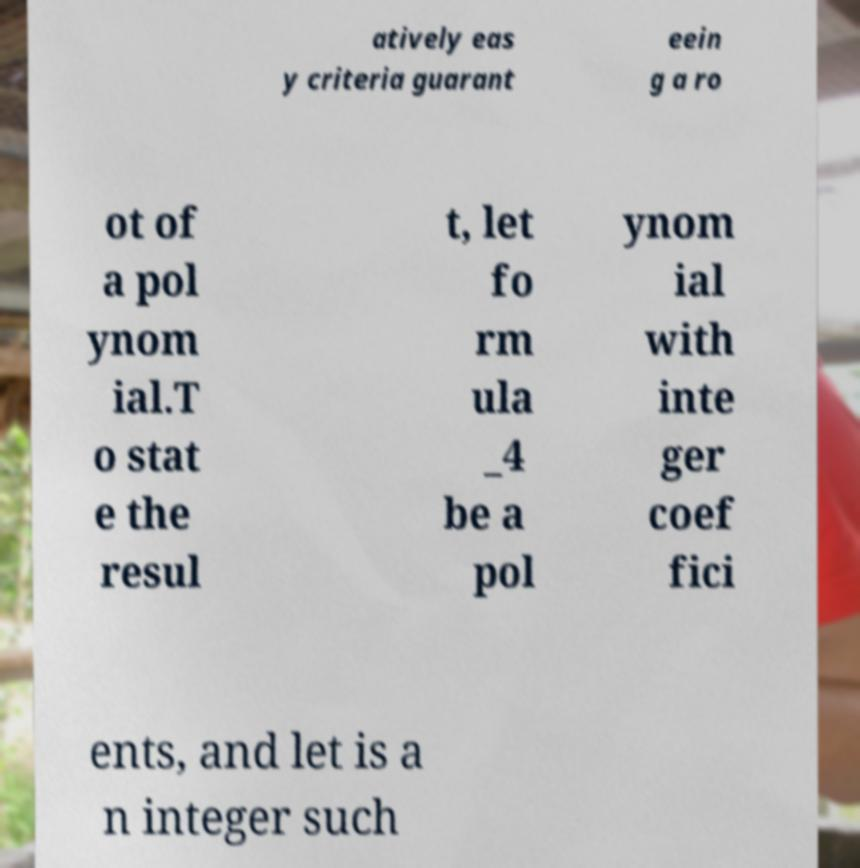I need the written content from this picture converted into text. Can you do that? atively eas y criteria guarant eein g a ro ot of a pol ynom ial.T o stat e the resul t, let fo rm ula _4 be a pol ynom ial with inte ger coef fici ents, and let is a n integer such 